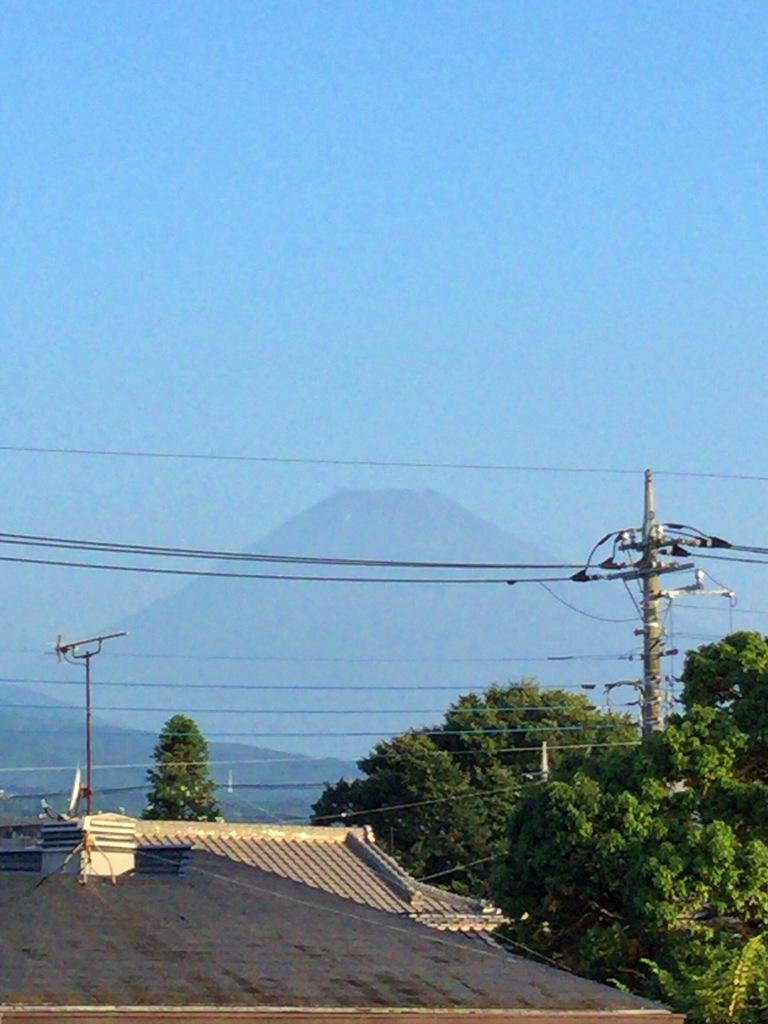What type of structures can be seen in the image? There are houses in the image. What natural elements are present in the image? There are trees in the image. What man-made objects can be seen in the image? Cables and poles are visible in the image. What geographical features are visible in the image? There are hills in the image. What type of pipe can be seen running through the houses in the image? There is no pipe running through the houses in the image; only houses, trees, cables, poles, and hills are present. What type of milk is being delivered to the houses in the image? There is no milk delivery or any milk visible in the image. 